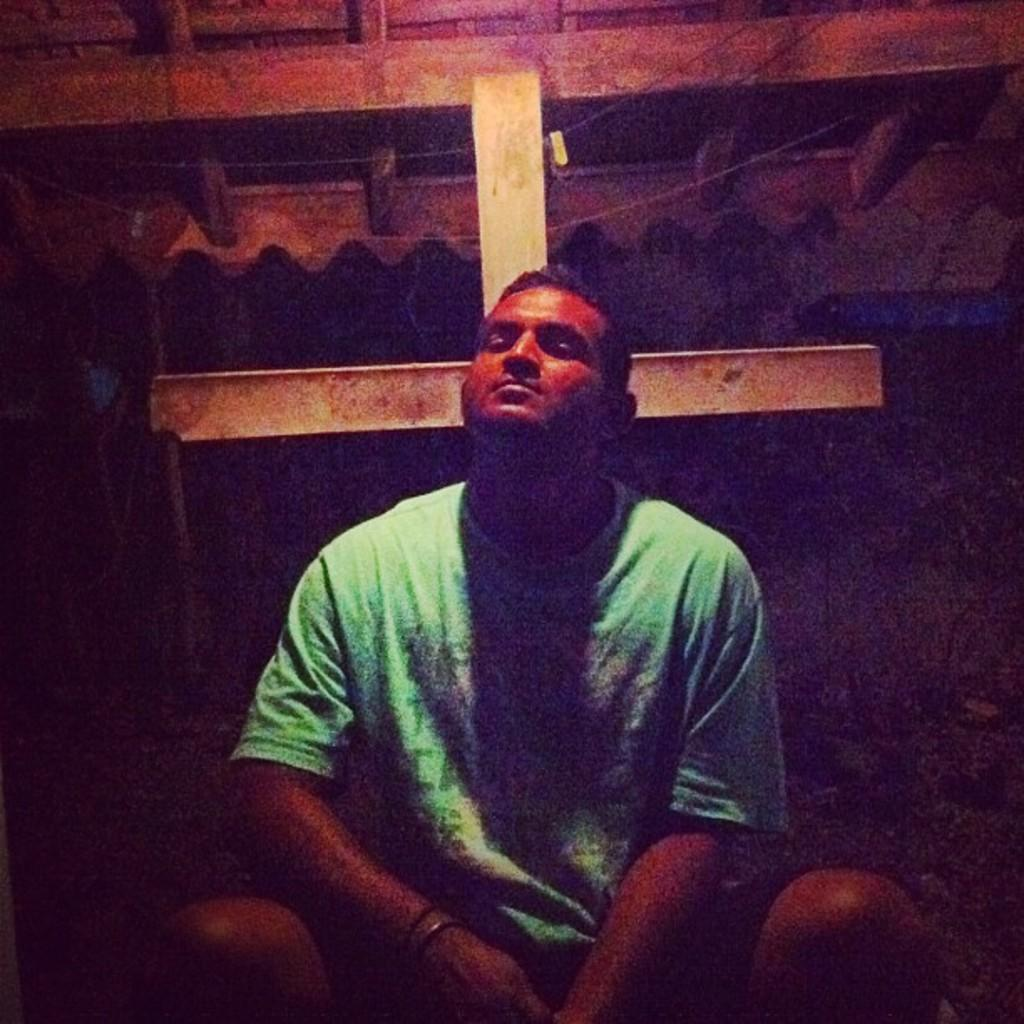Who or what is present in the image? There is a person in the image. What is the person doing in the image? The person is sitting. Where is the person located in the image? The person is under the roof of a house. What type of question is being asked by the person in the image? There is no indication in the image that the person is asking a question. 